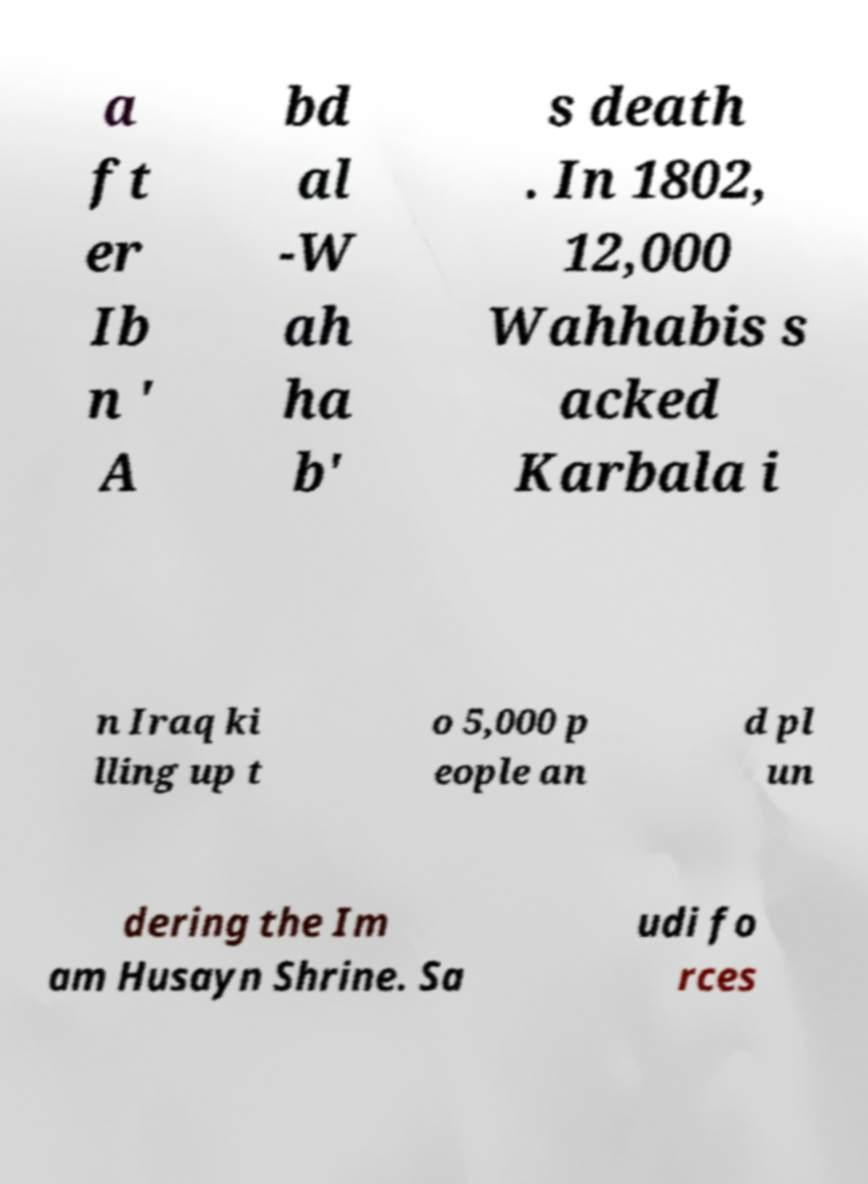For documentation purposes, I need the text within this image transcribed. Could you provide that? a ft er Ib n ' A bd al -W ah ha b' s death . In 1802, 12,000 Wahhabis s acked Karbala i n Iraq ki lling up t o 5,000 p eople an d pl un dering the Im am Husayn Shrine. Sa udi fo rces 